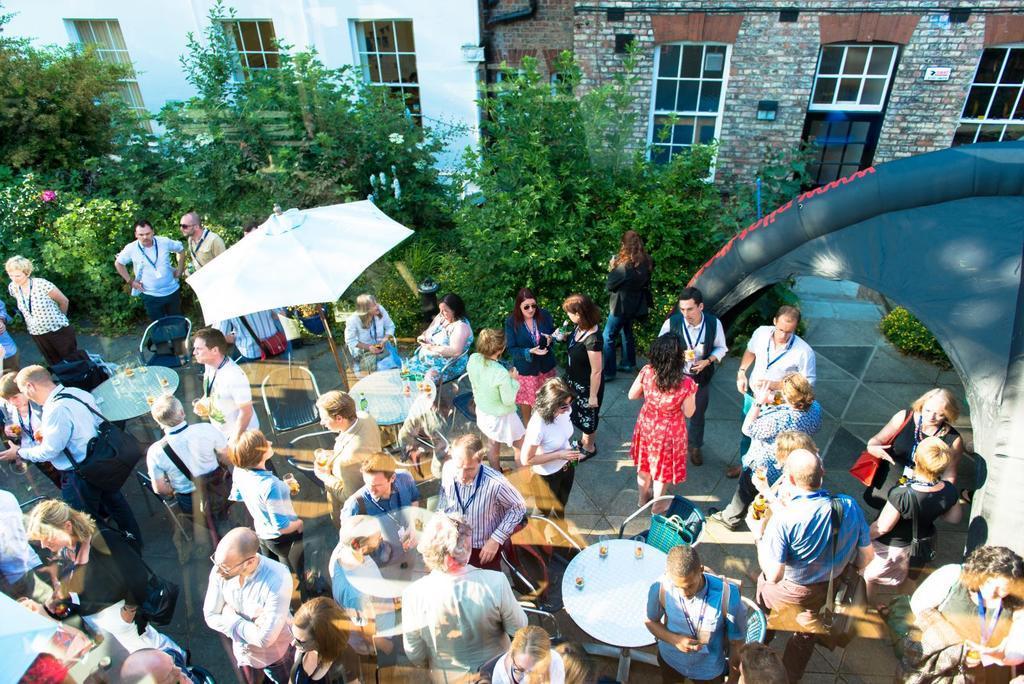Please provide a concise description of this image. There are groups of people standing and few people sitting. These are the tables and chairs. This is a kind of a patio umbrella, which is white in color. I can see the trees and plants. These are the buildings with the windows. This looks like an inflatable balloon, which is black in color. 